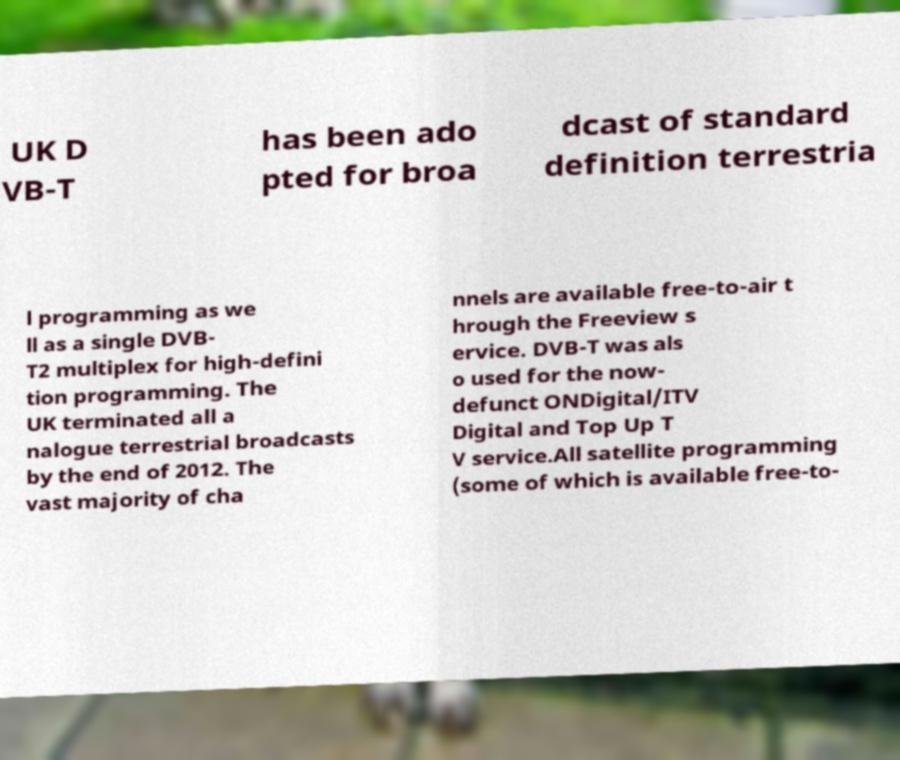Can you accurately transcribe the text from the provided image for me? UK D VB-T has been ado pted for broa dcast of standard definition terrestria l programming as we ll as a single DVB- T2 multiplex for high-defini tion programming. The UK terminated all a nalogue terrestrial broadcasts by the end of 2012. The vast majority of cha nnels are available free-to-air t hrough the Freeview s ervice. DVB-T was als o used for the now- defunct ONDigital/ITV Digital and Top Up T V service.All satellite programming (some of which is available free-to- 